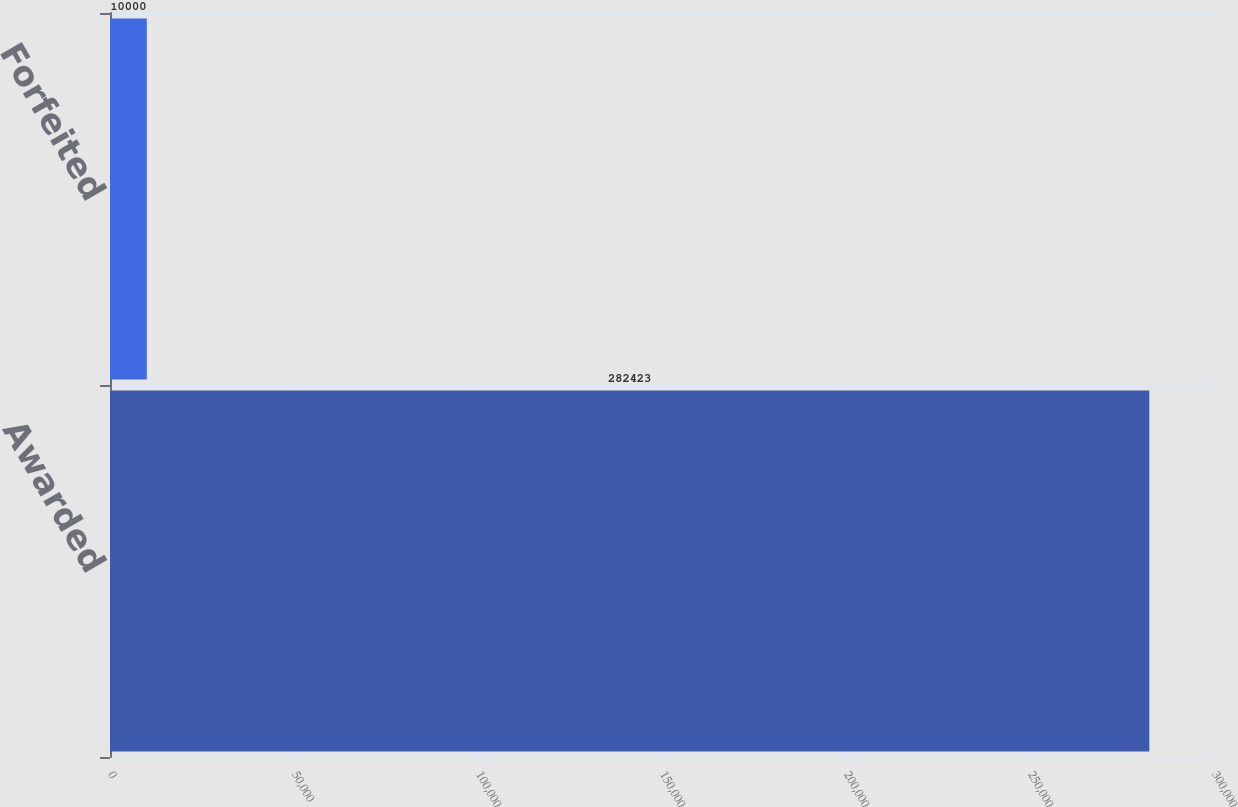Convert chart to OTSL. <chart><loc_0><loc_0><loc_500><loc_500><bar_chart><fcel>Awarded<fcel>Forfeited<nl><fcel>282423<fcel>10000<nl></chart> 